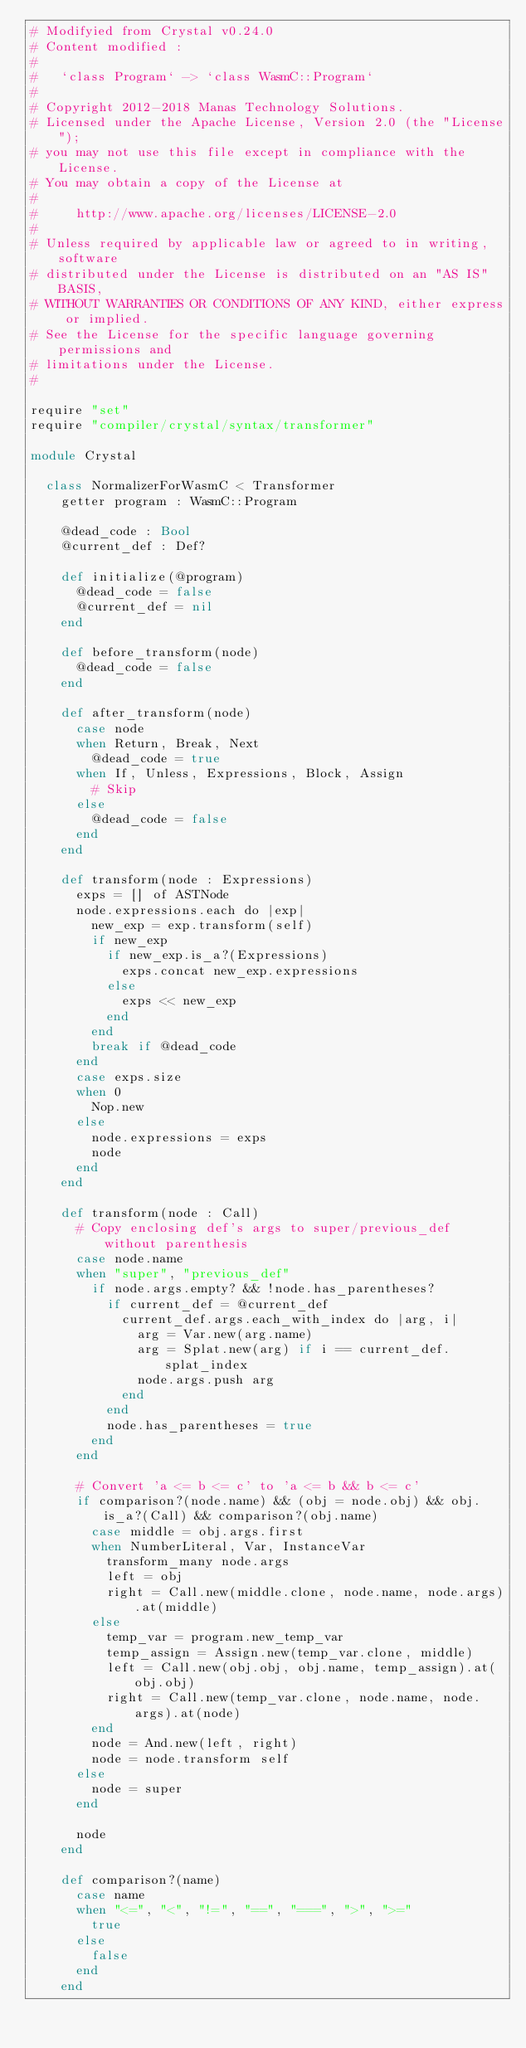Convert code to text. <code><loc_0><loc_0><loc_500><loc_500><_Crystal_># Modifyied from Crystal v0.24.0
# Content modified :
# 
#   `class Program` -> `class WasmC::Program`
# 
# Copyright 2012-2018 Manas Technology Solutions.
# Licensed under the Apache License, Version 2.0 (the "License");
# you may not use this file except in compliance with the License.
# You may obtain a copy of the License at
#
#     http://www.apache.org/licenses/LICENSE-2.0
#
# Unless required by applicable law or agreed to in writing, software
# distributed under the License is distributed on an "AS IS" BASIS,
# WITHOUT WARRANTIES OR CONDITIONS OF ANY KIND, either express or implied.
# See the License for the specific language governing permissions and
# limitations under the License.
#

require "set"
require "compiler/crystal/syntax/transformer"

module Crystal

  class NormalizerForWasmC < Transformer
    getter program : WasmC::Program

    @dead_code : Bool
    @current_def : Def?

    def initialize(@program)
      @dead_code = false
      @current_def = nil
    end

    def before_transform(node)
      @dead_code = false
    end

    def after_transform(node)
      case node
      when Return, Break, Next
        @dead_code = true
      when If, Unless, Expressions, Block, Assign
        # Skip
      else
        @dead_code = false
      end
    end

    def transform(node : Expressions)
      exps = [] of ASTNode
      node.expressions.each do |exp|
        new_exp = exp.transform(self)
        if new_exp
          if new_exp.is_a?(Expressions)
            exps.concat new_exp.expressions
          else
            exps << new_exp
          end
        end
        break if @dead_code
      end
      case exps.size
      when 0
        Nop.new
      else
        node.expressions = exps
        node
      end
    end

    def transform(node : Call)
      # Copy enclosing def's args to super/previous_def without parenthesis
      case node.name
      when "super", "previous_def"
        if node.args.empty? && !node.has_parentheses?
          if current_def = @current_def
            current_def.args.each_with_index do |arg, i|
              arg = Var.new(arg.name)
              arg = Splat.new(arg) if i == current_def.splat_index
              node.args.push arg
            end
          end
          node.has_parentheses = true
        end
      end

      # Convert 'a <= b <= c' to 'a <= b && b <= c'
      if comparison?(node.name) && (obj = node.obj) && obj.is_a?(Call) && comparison?(obj.name)
        case middle = obj.args.first
        when NumberLiteral, Var, InstanceVar
          transform_many node.args
          left = obj
          right = Call.new(middle.clone, node.name, node.args).at(middle)
        else
          temp_var = program.new_temp_var
          temp_assign = Assign.new(temp_var.clone, middle)
          left = Call.new(obj.obj, obj.name, temp_assign).at(obj.obj)
          right = Call.new(temp_var.clone, node.name, node.args).at(node)
        end
        node = And.new(left, right)
        node = node.transform self
      else
        node = super
      end

      node
    end

    def comparison?(name)
      case name
      when "<=", "<", "!=", "==", "===", ">", ">="
        true
      else
        false
      end
    end
</code> 